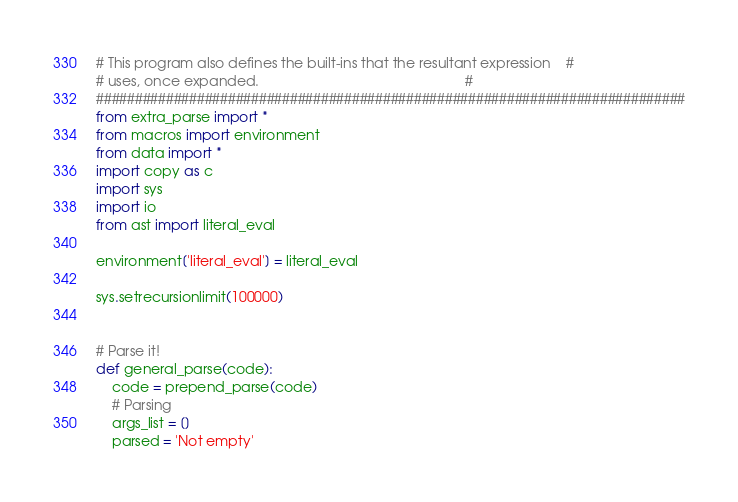Convert code to text. <code><loc_0><loc_0><loc_500><loc_500><_Python_># This program also defines the built-ins that the resultant expression    #
# uses, once expanded.                                                     #
############################################################################
from extra_parse import *
from macros import environment
from data import *
import copy as c
import sys
import io
from ast import literal_eval

environment['literal_eval'] = literal_eval

sys.setrecursionlimit(100000)


# Parse it!
def general_parse(code):
    code = prepend_parse(code)
    # Parsing
    args_list = []
    parsed = 'Not empty'</code> 